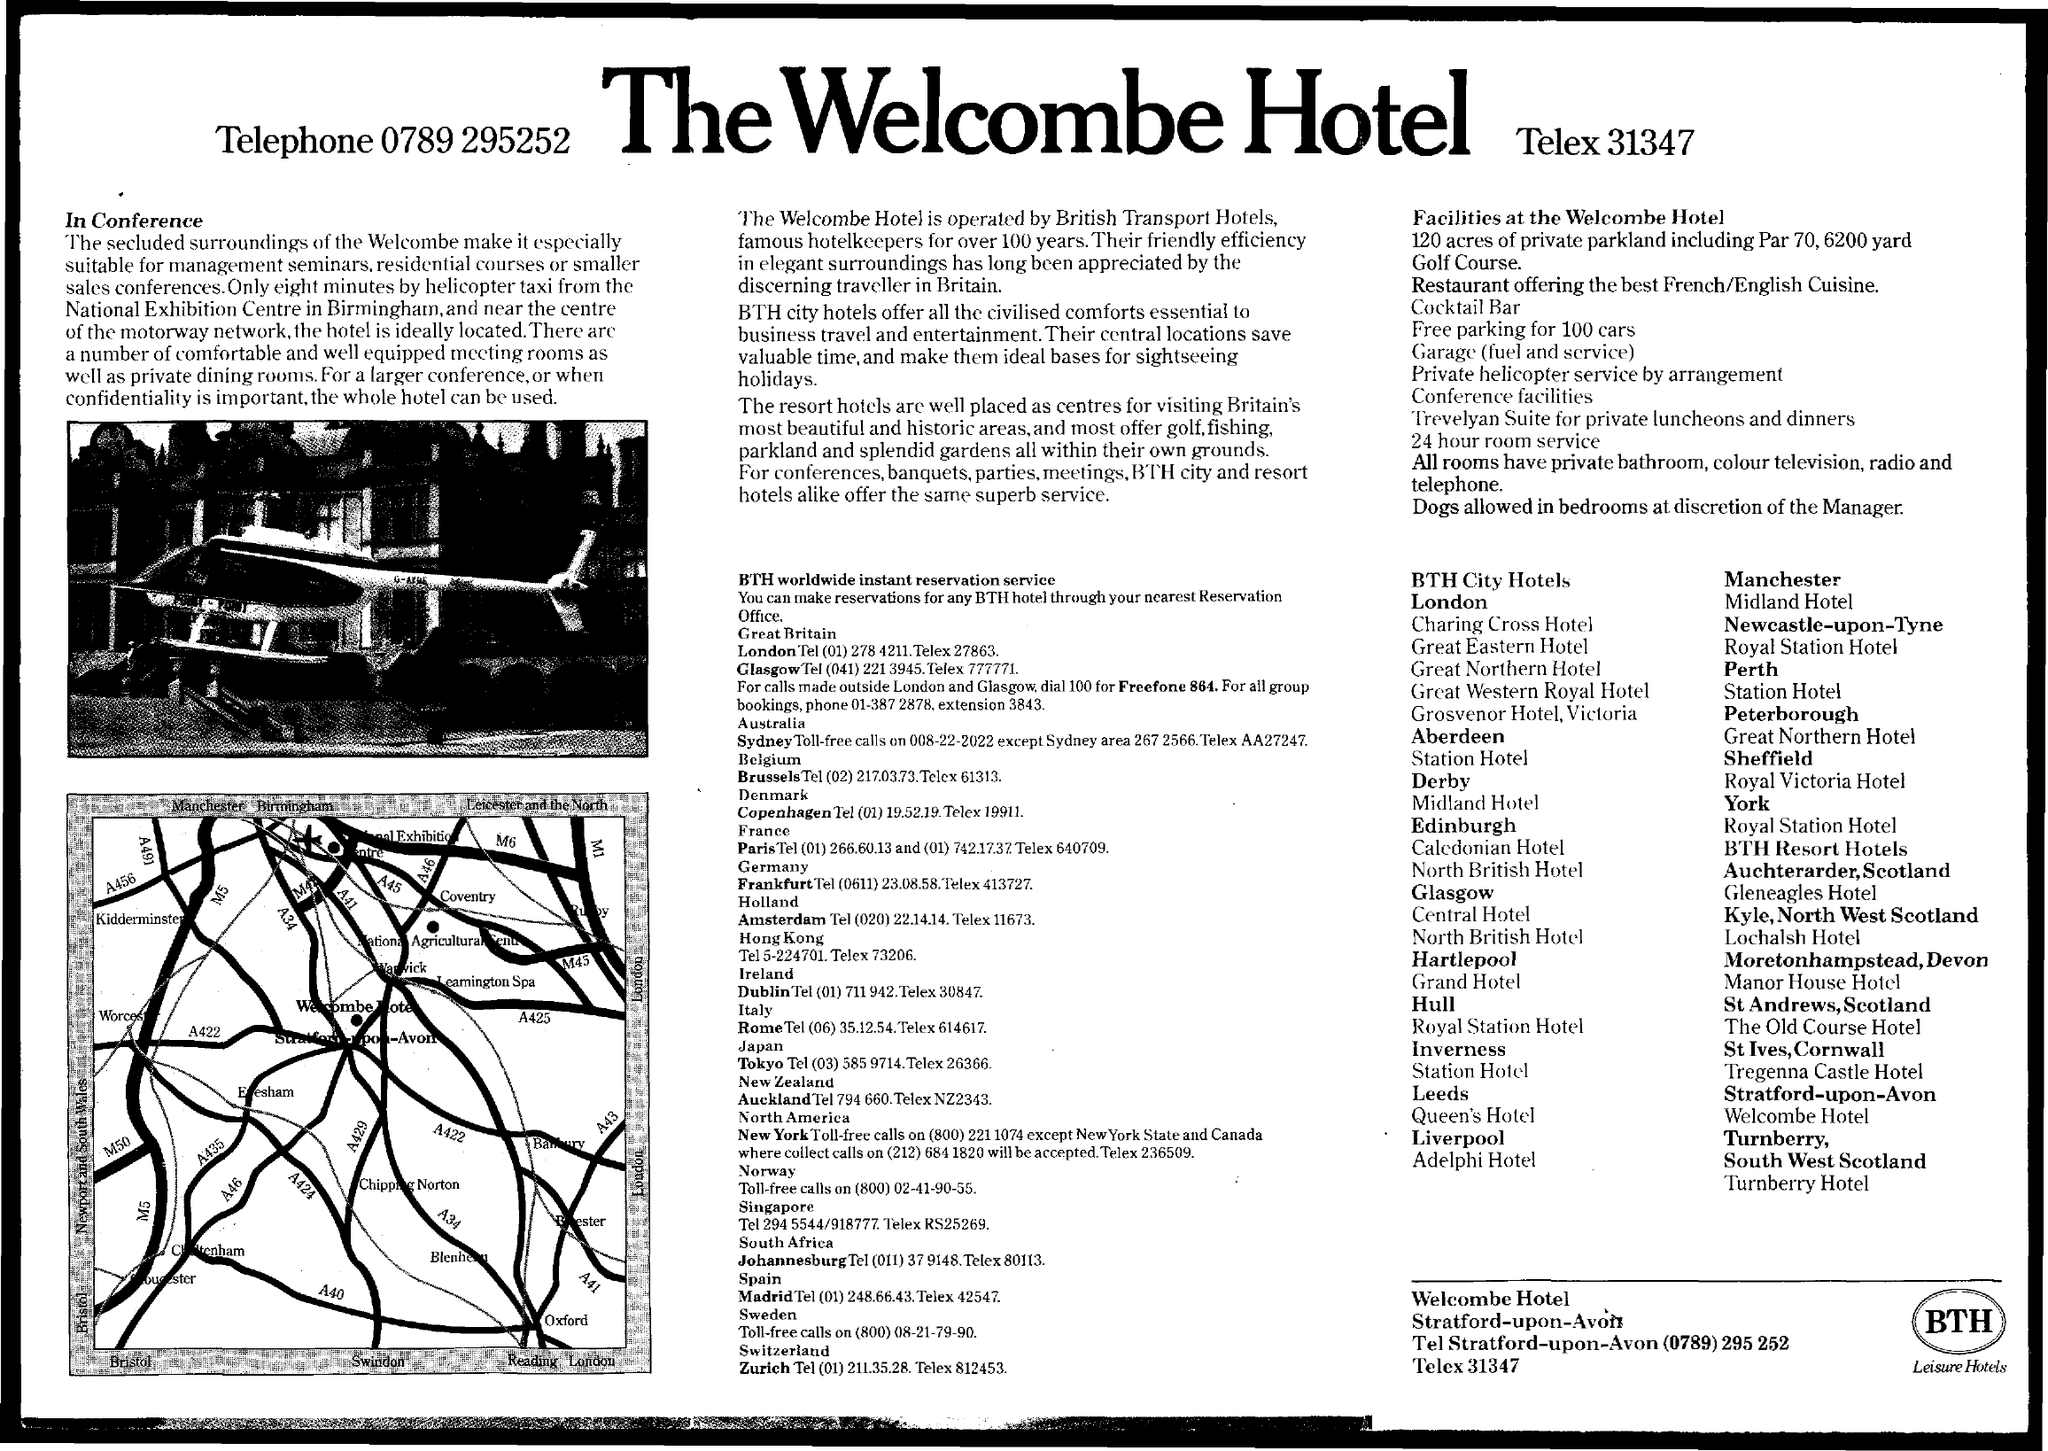What is the name of the Hotel?
Ensure brevity in your answer.  The Welcombe Hotel. What is the Telex of the hotel?
Your response must be concise. 31347. 